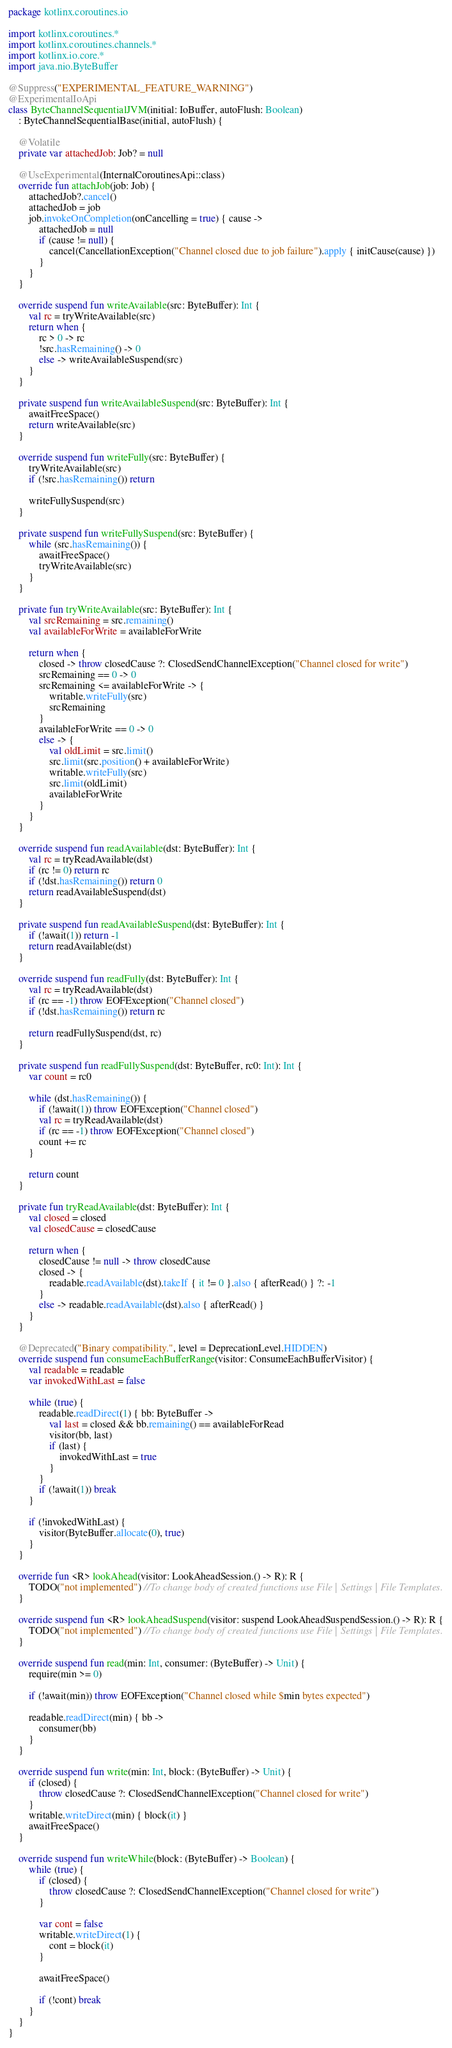Convert code to text. <code><loc_0><loc_0><loc_500><loc_500><_Kotlin_>package kotlinx.coroutines.io

import kotlinx.coroutines.*
import kotlinx.coroutines.channels.*
import kotlinx.io.core.*
import java.nio.ByteBuffer

@Suppress("EXPERIMENTAL_FEATURE_WARNING")
@ExperimentalIoApi
class ByteChannelSequentialJVM(initial: IoBuffer, autoFlush: Boolean)
    : ByteChannelSequentialBase(initial, autoFlush) {

    @Volatile
    private var attachedJob: Job? = null

    @UseExperimental(InternalCoroutinesApi::class)
    override fun attachJob(job: Job) {
        attachedJob?.cancel()
        attachedJob = job
        job.invokeOnCompletion(onCancelling = true) { cause ->
            attachedJob = null
            if (cause != null) {
                cancel(CancellationException("Channel closed due to job failure").apply { initCause(cause) })
            }
        }
    }

    override suspend fun writeAvailable(src: ByteBuffer): Int {
        val rc = tryWriteAvailable(src)
        return when {
            rc > 0 -> rc
            !src.hasRemaining() -> 0
            else -> writeAvailableSuspend(src)
        }
    }

    private suspend fun writeAvailableSuspend(src: ByteBuffer): Int {
        awaitFreeSpace()
        return writeAvailable(src)
    }

    override suspend fun writeFully(src: ByteBuffer) {
        tryWriteAvailable(src)
        if (!src.hasRemaining()) return

        writeFullySuspend(src)
    }

    private suspend fun writeFullySuspend(src: ByteBuffer) {
        while (src.hasRemaining()) {
            awaitFreeSpace()
            tryWriteAvailable(src)
        }
    }

    private fun tryWriteAvailable(src: ByteBuffer): Int {
        val srcRemaining = src.remaining()
        val availableForWrite = availableForWrite

        return when {
            closed -> throw closedCause ?: ClosedSendChannelException("Channel closed for write")
            srcRemaining == 0 -> 0
            srcRemaining <= availableForWrite -> {
                writable.writeFully(src)
                srcRemaining
            }
            availableForWrite == 0 -> 0
            else -> {
                val oldLimit = src.limit()
                src.limit(src.position() + availableForWrite)
                writable.writeFully(src)
                src.limit(oldLimit)
                availableForWrite
            }
        }
    }

    override suspend fun readAvailable(dst: ByteBuffer): Int {
        val rc = tryReadAvailable(dst)
        if (rc != 0) return rc
        if (!dst.hasRemaining()) return 0
        return readAvailableSuspend(dst)
    }

    private suspend fun readAvailableSuspend(dst: ByteBuffer): Int {
        if (!await(1)) return -1
        return readAvailable(dst)
    }

    override suspend fun readFully(dst: ByteBuffer): Int {
        val rc = tryReadAvailable(dst)
        if (rc == -1) throw EOFException("Channel closed")
        if (!dst.hasRemaining()) return rc

        return readFullySuspend(dst, rc)
    }

    private suspend fun readFullySuspend(dst: ByteBuffer, rc0: Int): Int {
        var count = rc0

        while (dst.hasRemaining()) {
            if (!await(1)) throw EOFException("Channel closed")
            val rc = tryReadAvailable(dst)
            if (rc == -1) throw EOFException("Channel closed")
            count += rc
        }

        return count
    }

    private fun tryReadAvailable(dst: ByteBuffer): Int {
        val closed = closed
        val closedCause = closedCause

        return when {
            closedCause != null -> throw closedCause
            closed -> {
                readable.readAvailable(dst).takeIf { it != 0 }.also { afterRead() } ?: -1
            }
            else -> readable.readAvailable(dst).also { afterRead() }
        }
    }

    @Deprecated("Binary compatibility.", level = DeprecationLevel.HIDDEN)
    override suspend fun consumeEachBufferRange(visitor: ConsumeEachBufferVisitor) {
        val readable = readable
        var invokedWithLast = false

        while (true) {
            readable.readDirect(1) { bb: ByteBuffer ->
                val last = closed && bb.remaining() == availableForRead
                visitor(bb, last)
                if (last) {
                    invokedWithLast = true
                }
            }
            if (!await(1)) break
        }

        if (!invokedWithLast) {
            visitor(ByteBuffer.allocate(0), true)
        }
    }

    override fun <R> lookAhead(visitor: LookAheadSession.() -> R): R {
        TODO("not implemented") //To change body of created functions use File | Settings | File Templates.
    }

    override suspend fun <R> lookAheadSuspend(visitor: suspend LookAheadSuspendSession.() -> R): R {
        TODO("not implemented") //To change body of created functions use File | Settings | File Templates.
    }

    override suspend fun read(min: Int, consumer: (ByteBuffer) -> Unit) {
        require(min >= 0)

        if (!await(min)) throw EOFException("Channel closed while $min bytes expected")

        readable.readDirect(min) { bb ->
            consumer(bb)
        }
    }

    override suspend fun write(min: Int, block: (ByteBuffer) -> Unit) {
        if (closed) {
            throw closedCause ?: ClosedSendChannelException("Channel closed for write")
        }
        writable.writeDirect(min) { block(it) }
        awaitFreeSpace()
    }

    override suspend fun writeWhile(block: (ByteBuffer) -> Boolean) {
        while (true) {
            if (closed) {
                throw closedCause ?: ClosedSendChannelException("Channel closed for write")
            }

            var cont = false
            writable.writeDirect(1) {
                cont = block(it)
            }

            awaitFreeSpace()

            if (!cont) break
        }
    }
}

</code> 